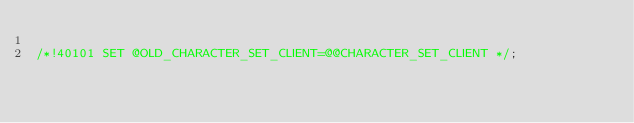Convert code to text. <code><loc_0><loc_0><loc_500><loc_500><_SQL_>
/*!40101 SET @OLD_CHARACTER_SET_CLIENT=@@CHARACTER_SET_CLIENT */;</code> 